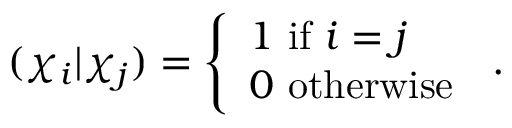Convert formula to latex. <formula><loc_0><loc_0><loc_500><loc_500>( \chi _ { i } | \chi _ { j } ) = { \left \{ \begin{array} { l l } { 1 { i f } i = j } \\ { 0 { o t h e r w i s e } } \end{array} } .</formula> 